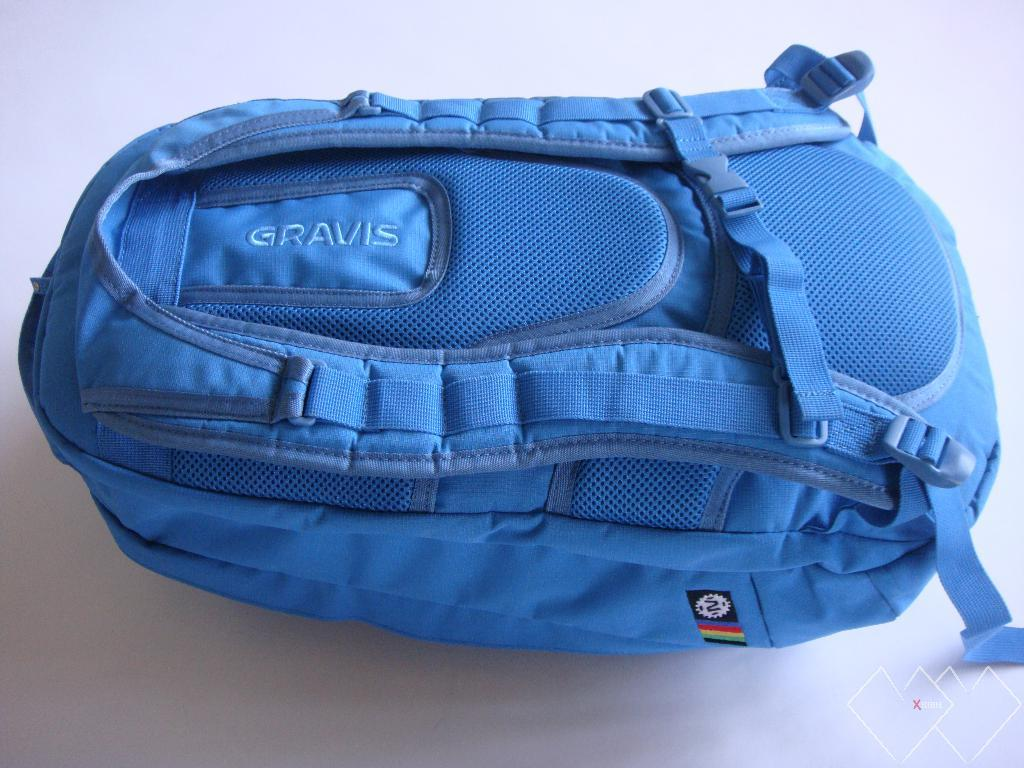What type of bag can be seen in the image? There is a blue colored backpack bag in the image. What other type of bag is present in the image? There is a clutch in the image. Is there any additional detail on the backpack bag? Yes, a colored label is attached to the backpack bag. How many pigs are running around the backpack bag in the image? There are no pigs present in the image; it only features a blue colored backpack bag and a clutch. 